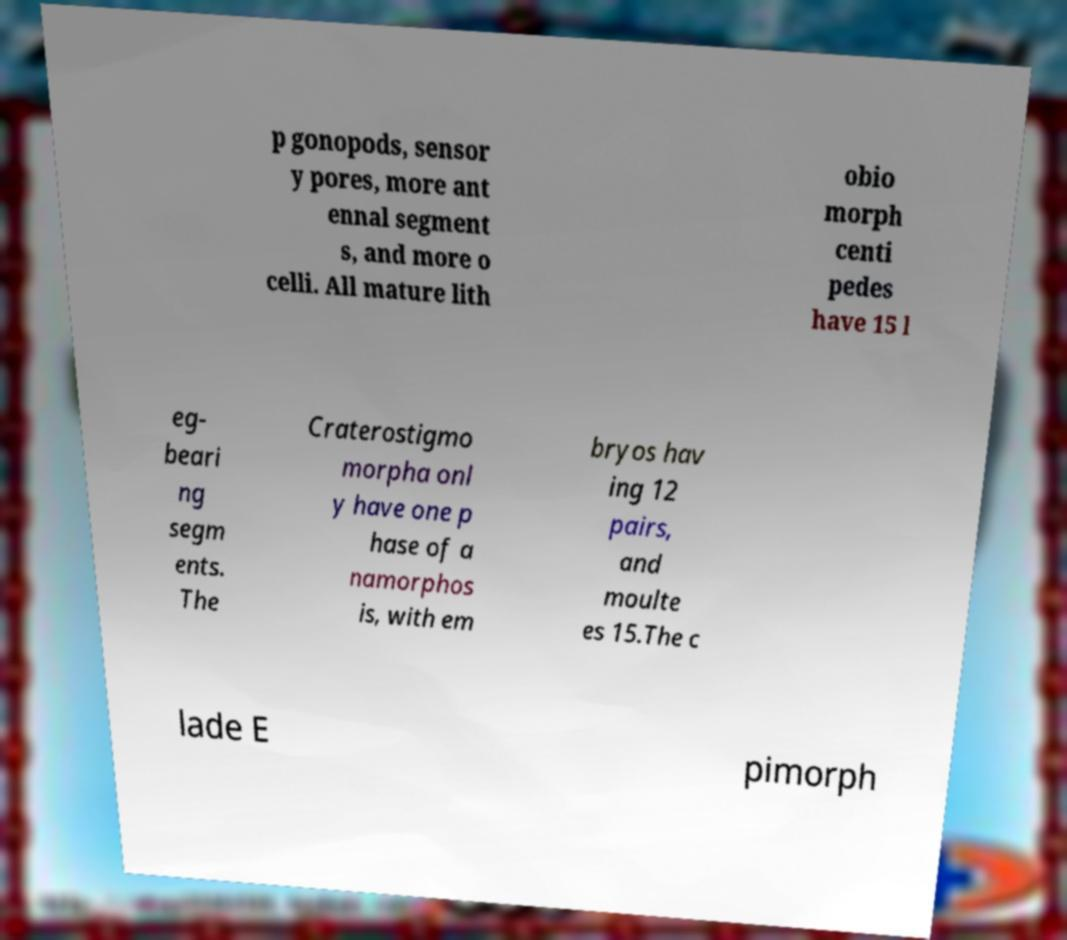Can you read and provide the text displayed in the image?This photo seems to have some interesting text. Can you extract and type it out for me? p gonopods, sensor y pores, more ant ennal segment s, and more o celli. All mature lith obio morph centi pedes have 15 l eg- beari ng segm ents. The Craterostigmo morpha onl y have one p hase of a namorphos is, with em bryos hav ing 12 pairs, and moulte es 15.The c lade E pimorph 